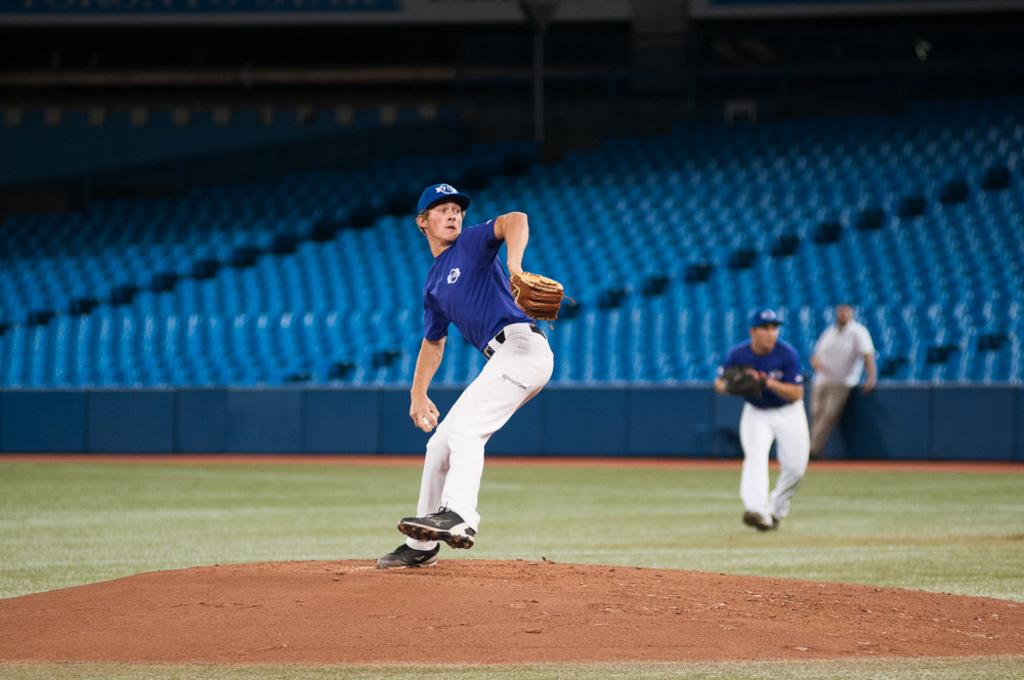How many people are in the image? There are three people in the image. What are two of the people doing in the image? Two of the people are playing baseball. Who is holding the ball in the image? One person is holding a ball. What can be seen in the background of the image? There are seats visible in the background. How would you describe the background of the image? The background is blurred. What type of coat is the person wearing while making an error in the image? There is no mention of a coat or an error in the image. The image features people playing baseball, with one person holding a ball, and seats visible in the background. 